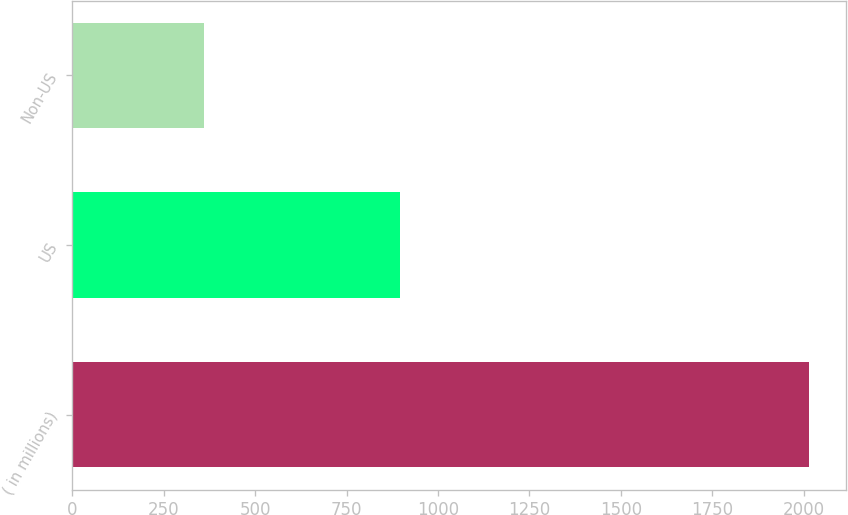Convert chart to OTSL. <chart><loc_0><loc_0><loc_500><loc_500><bar_chart><fcel>( in millions)<fcel>US<fcel>Non-US<nl><fcel>2015<fcel>896<fcel>359<nl></chart> 